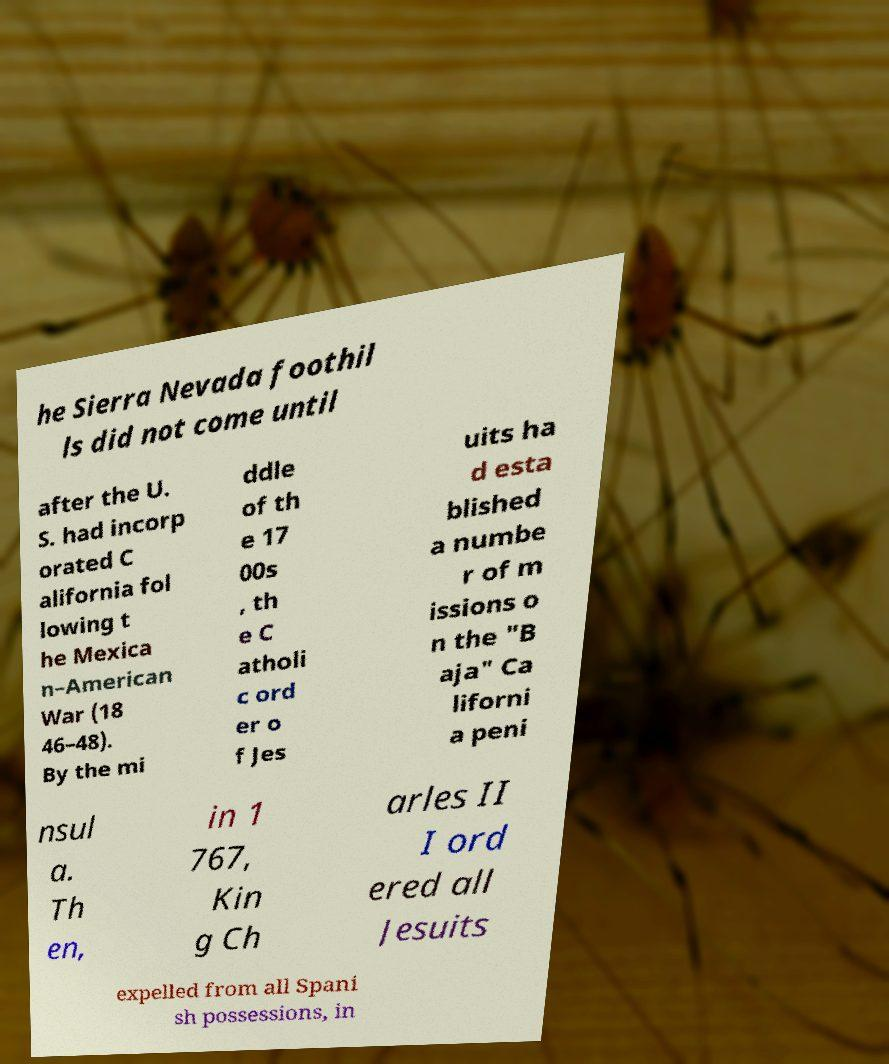Could you assist in decoding the text presented in this image and type it out clearly? he Sierra Nevada foothil ls did not come until after the U. S. had incorp orated C alifornia fol lowing t he Mexica n–American War (18 46–48). By the mi ddle of th e 17 00s , th e C atholi c ord er o f Jes uits ha d esta blished a numbe r of m issions o n the "B aja" Ca liforni a peni nsul a. Th en, in 1 767, Kin g Ch arles II I ord ered all Jesuits expelled from all Spani sh possessions, in 